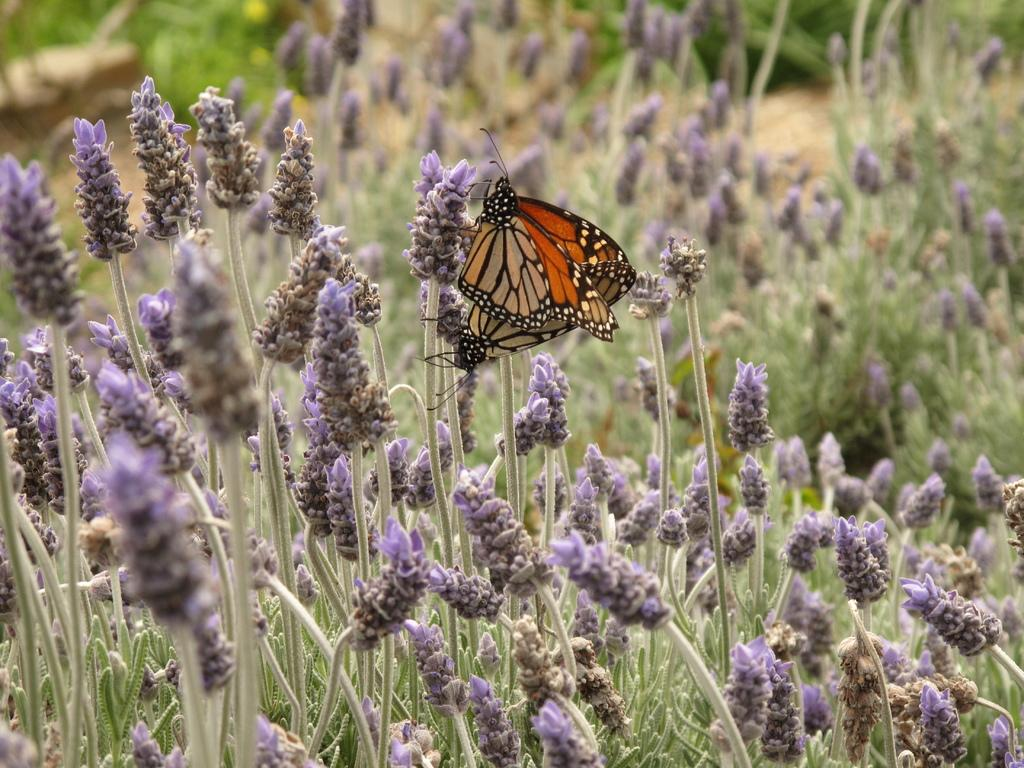What type of animals can be seen on the flowers in the image? There are butterflies on the flowers in the image. What can be seen in the background of the image? There are plants visible in the background of the image. What type of flora is present in the image? There are flowers visible in the image. What type of creature is responsible for building the base in the image? There is no mention of a base or any creature building it in the image. 